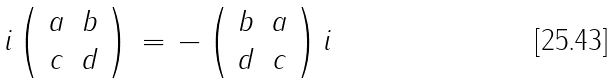<formula> <loc_0><loc_0><loc_500><loc_500>i \left ( \begin{array} { c c } { a } & { b } \\ { c } & { d } \end{array} \right ) \, = \, - \left ( \begin{array} { c c } { b } & { a } \\ { d } & { c } \end{array} \right ) i</formula> 